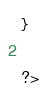<code> <loc_0><loc_0><loc_500><loc_500><_PHP_>}

?></code> 